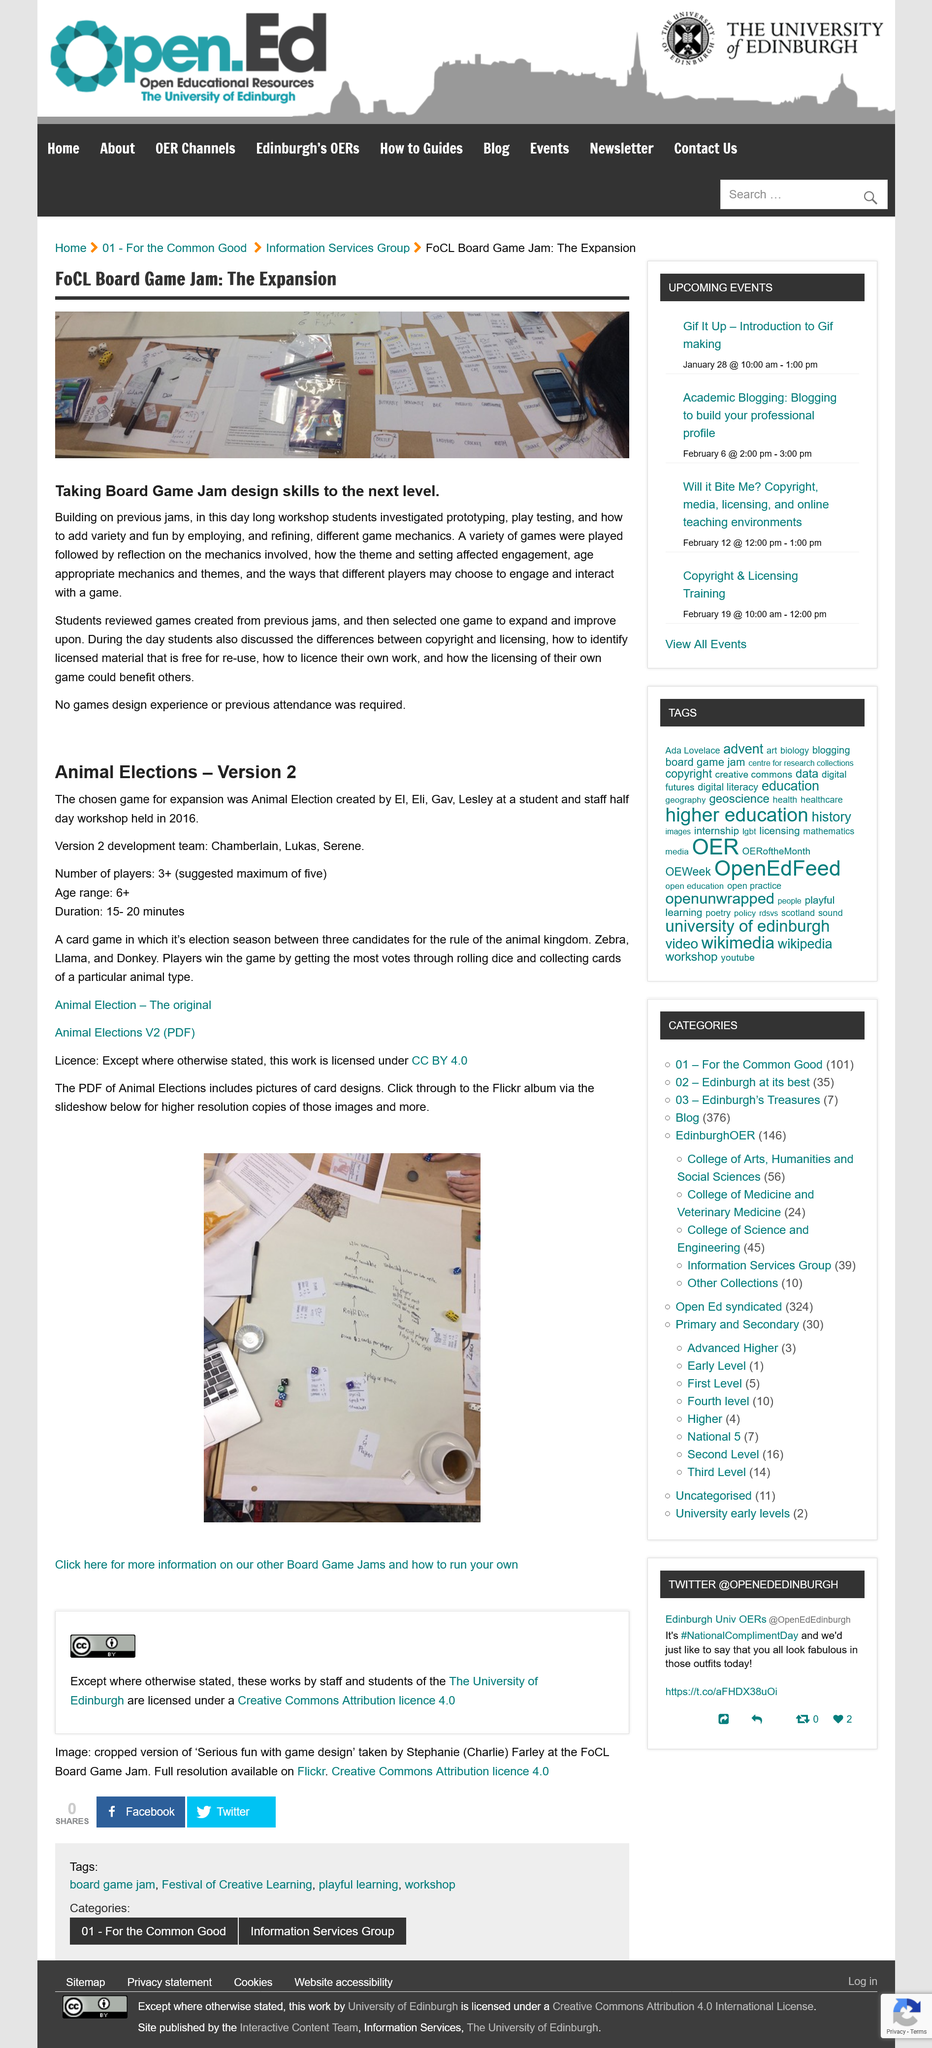Draw attention to some important aspects in this diagram. We have selected one game to expand and improve upon in order to achieve a better result. The requirement for previous games design experience was not necessary for students to attend the board game jam. Previous game jams were reviewed by students who created games from them. 